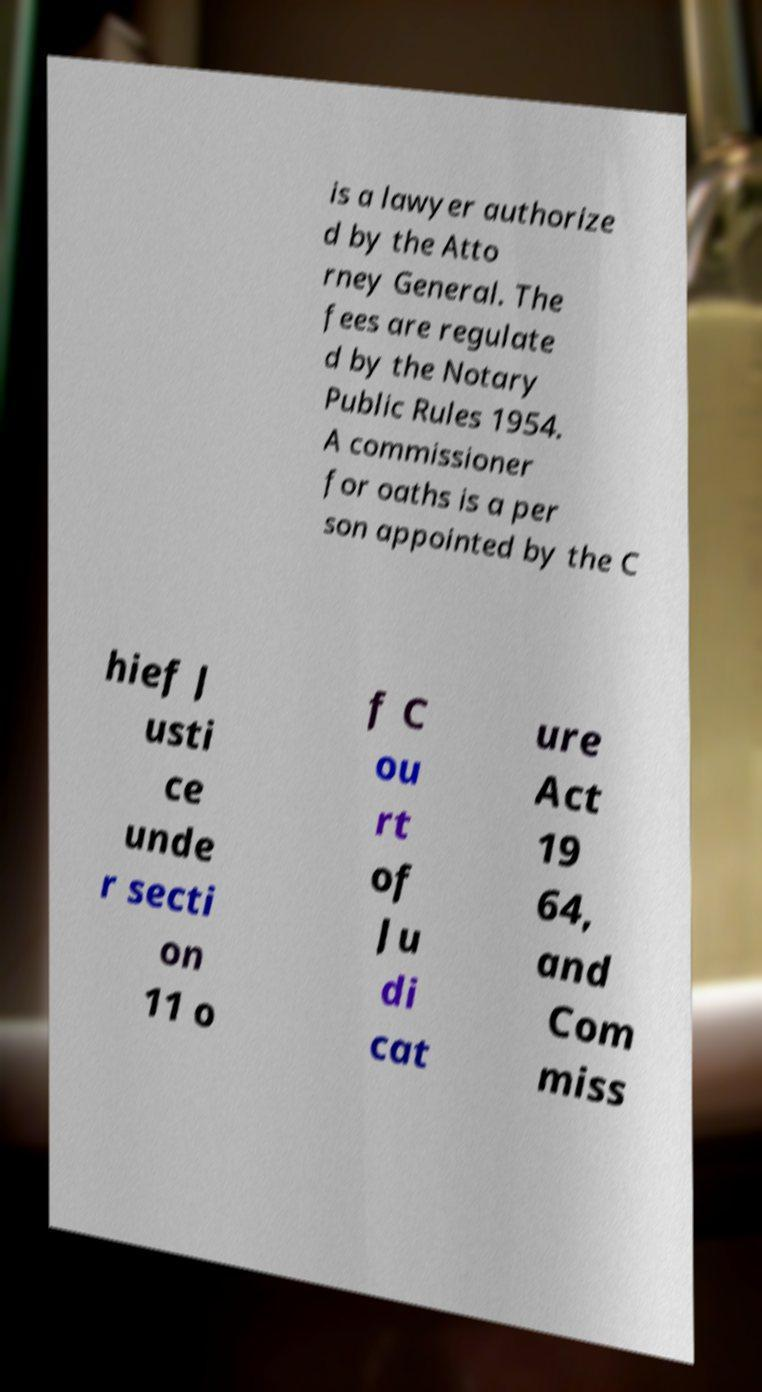I need the written content from this picture converted into text. Can you do that? is a lawyer authorize d by the Atto rney General. The fees are regulate d by the Notary Public Rules 1954. A commissioner for oaths is a per son appointed by the C hief J usti ce unde r secti on 11 o f C ou rt of Ju di cat ure Act 19 64, and Com miss 